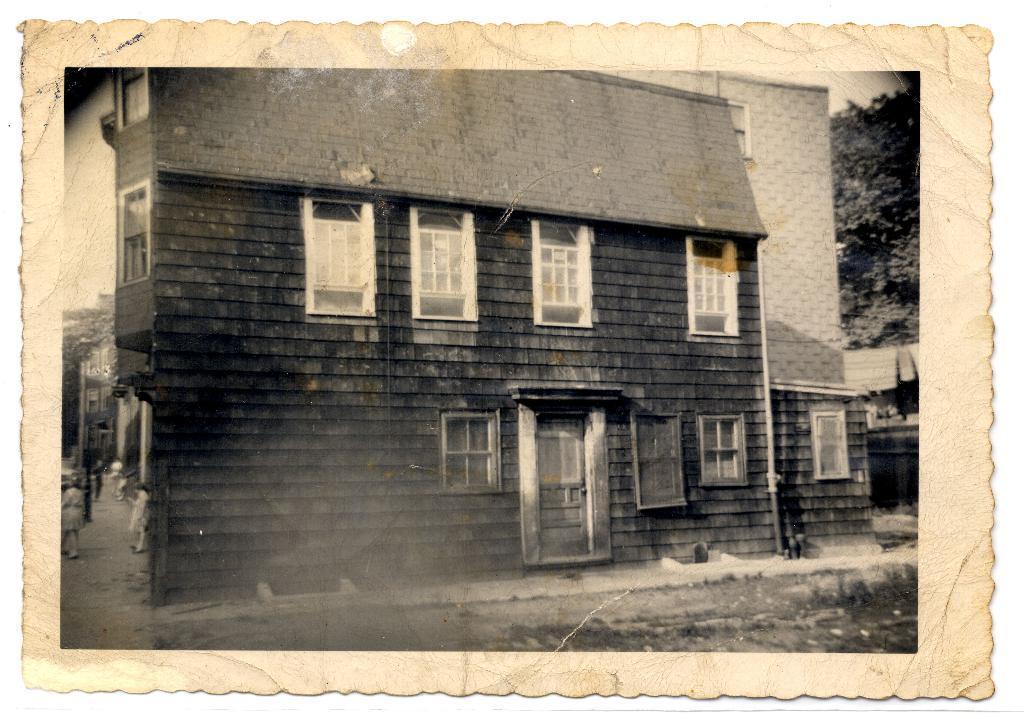How would you summarize this image in a sentence or two? In this picture we can see a photograph, here we can see few people on the road and we can see a building and trees. 